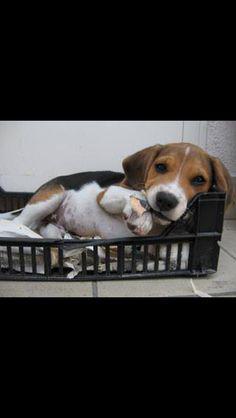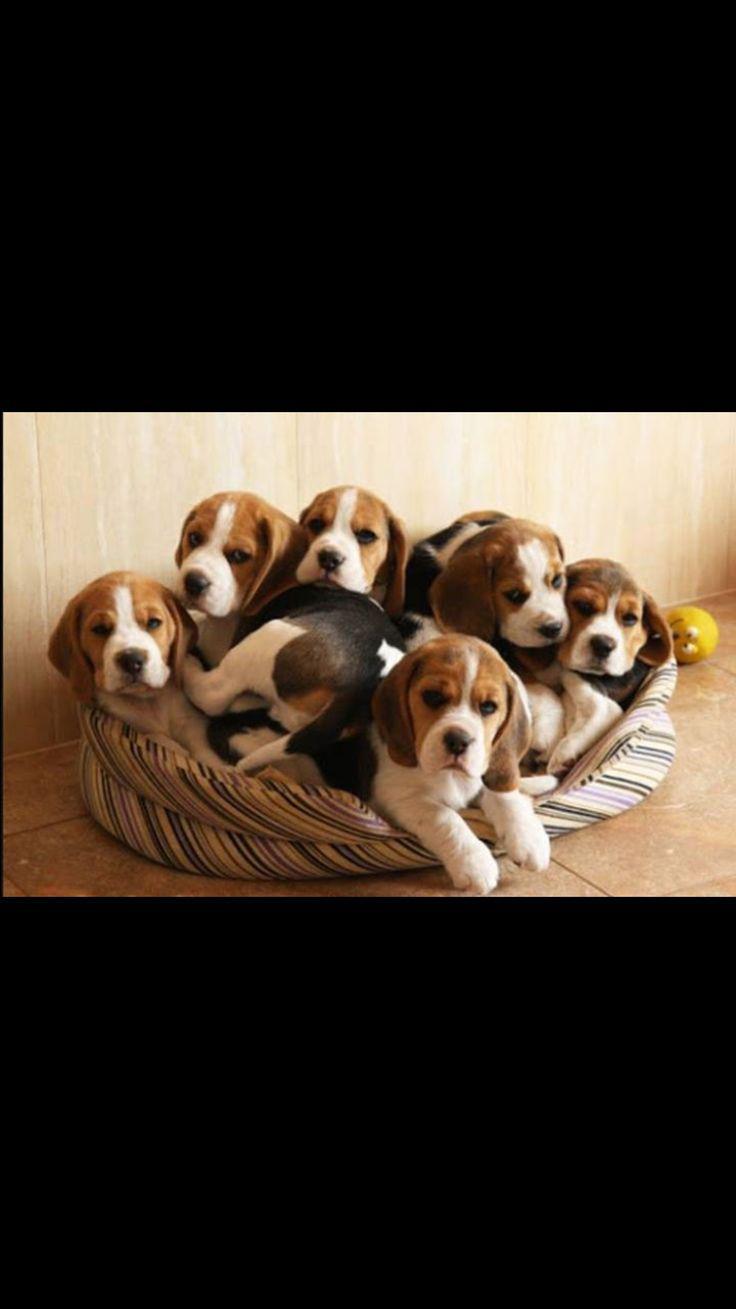The first image is the image on the left, the second image is the image on the right. Evaluate the accuracy of this statement regarding the images: "Two dogs are sleeping together in one of the images.". Is it true? Answer yes or no. No. 